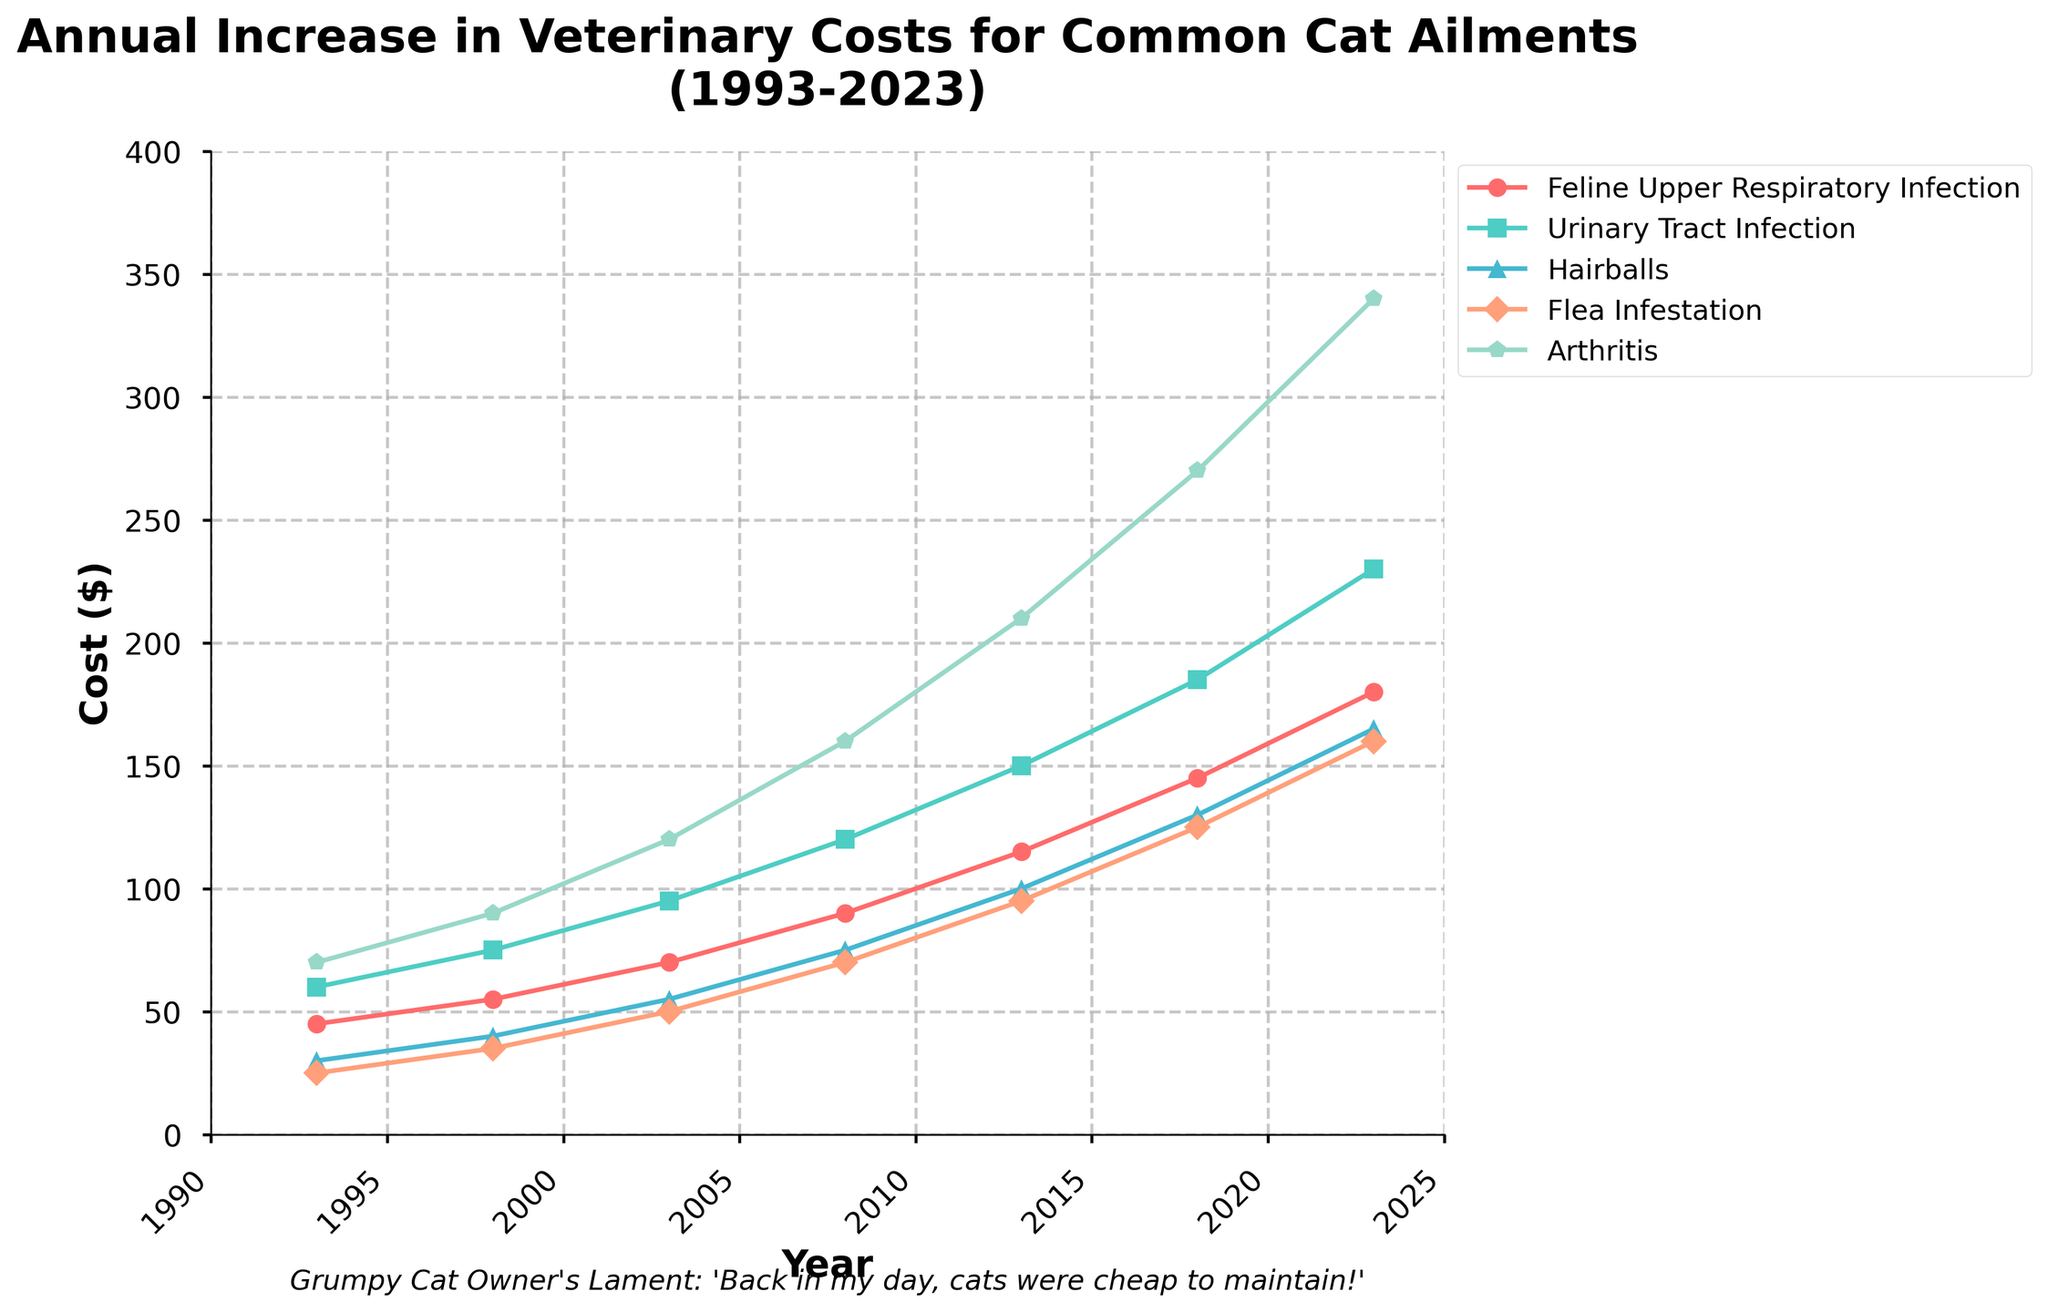What's the average cost of treating a Urinary Tract Infection (UTI) over the years? First, add up the costs listed for each year: (60 + 75 + 95 + 120 + 150 + 185 + 230) = 915. Then, divide by the number of years (7) to find the average: 915 / 7 = 130.71.
Answer: 130.71 How much more did it cost to treat Flea Infestation in 2023 compared to 1993? In 2023, the cost for Flea Infestation is $160. In 1993, it was $25. Subtract the 1993 cost from the 2023 cost: 160 - 25 = 135.
Answer: 135 Which ailment had the steepest increase in cost from 1993 to 2023? The steepest increase can be identified by computing the difference for each ailment over the period. The differences are: Feline Upper Respiratory Infection (180-45=135), Urinary Tract Infection (230-60=170), Hairballs (165-30=135), Flea Infestation (160-25=135), Arthritis (340-70=270). The largest difference is for Arthritis, with an increase of $270.
Answer: Arthritis By what percentage did the cost of treating Hairballs increase from 1993 to 2023? First, calculate the increase in cost: 165 - 30 = 135. Next, divide this by the original 1993 cost: 135 / 30 = 4.5. Multiply by 100 to get the percentage: 4.5 * 100 = 450%.
Answer: 450% Which year saw the largest single-year increase in cost for Feline Upper Respiratory Infection? Look at the differences per year sequence: (55–45=10), (70–55=15), (90–70=20), (115–90=25), (145–115=30), (180–145=35). The largest increase occurs between 2018 and 2023, with a rise of $35.
Answer: 2018 to 2023 Which ailment's cost increased the least from 1993 to 2023? Calculate the increase for each ailment. Differences are: Feline Upper Respiratory Infection (180-45=135), Urinary Tract Infection (230-60=170), Hairballs (165-30=135), Flea Infestation (160-25=135), Arthritis (340-70=270). The smallest difference is for Feline Upper Respiratory Infection (135).
Answer: Feline Upper Respiratory Infection How does the cost of treating Arthritis in 2008 compare to the cost of treating Flea Infestation in the same year? In 2008, the cost for Arthritis is $160 while for Flea Infestation it's $70. Compare these costs: 160 > 70
Answer: Arthritis is more expensive Which color line represents the cost trend for Urinary Tract Infection? Visually identify the color of the line associated with Urinary Tract Infection from the legend.
Answer: Green 